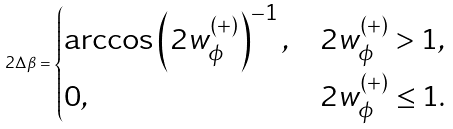<formula> <loc_0><loc_0><loc_500><loc_500>2 \Delta \beta = \begin{cases} \arccos \left ( 2 w ^ { ( + ) } _ { \phi } \right ) ^ { - 1 } , & 2 w ^ { ( + ) } _ { \phi } > 1 , \\ 0 , & 2 w ^ { ( + ) } _ { \phi } \leq 1 . \end{cases}</formula> 